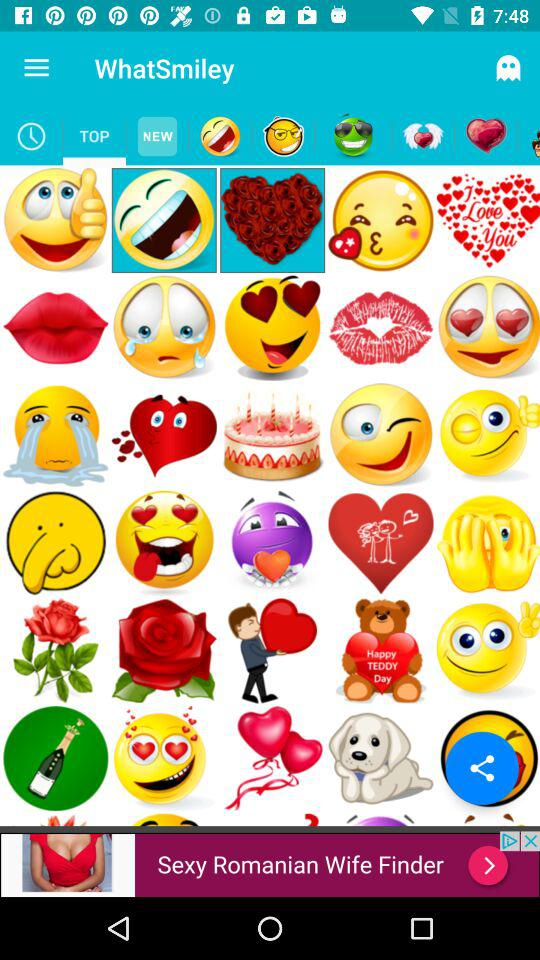Which tab is selected? The selected tab is "TOP". 